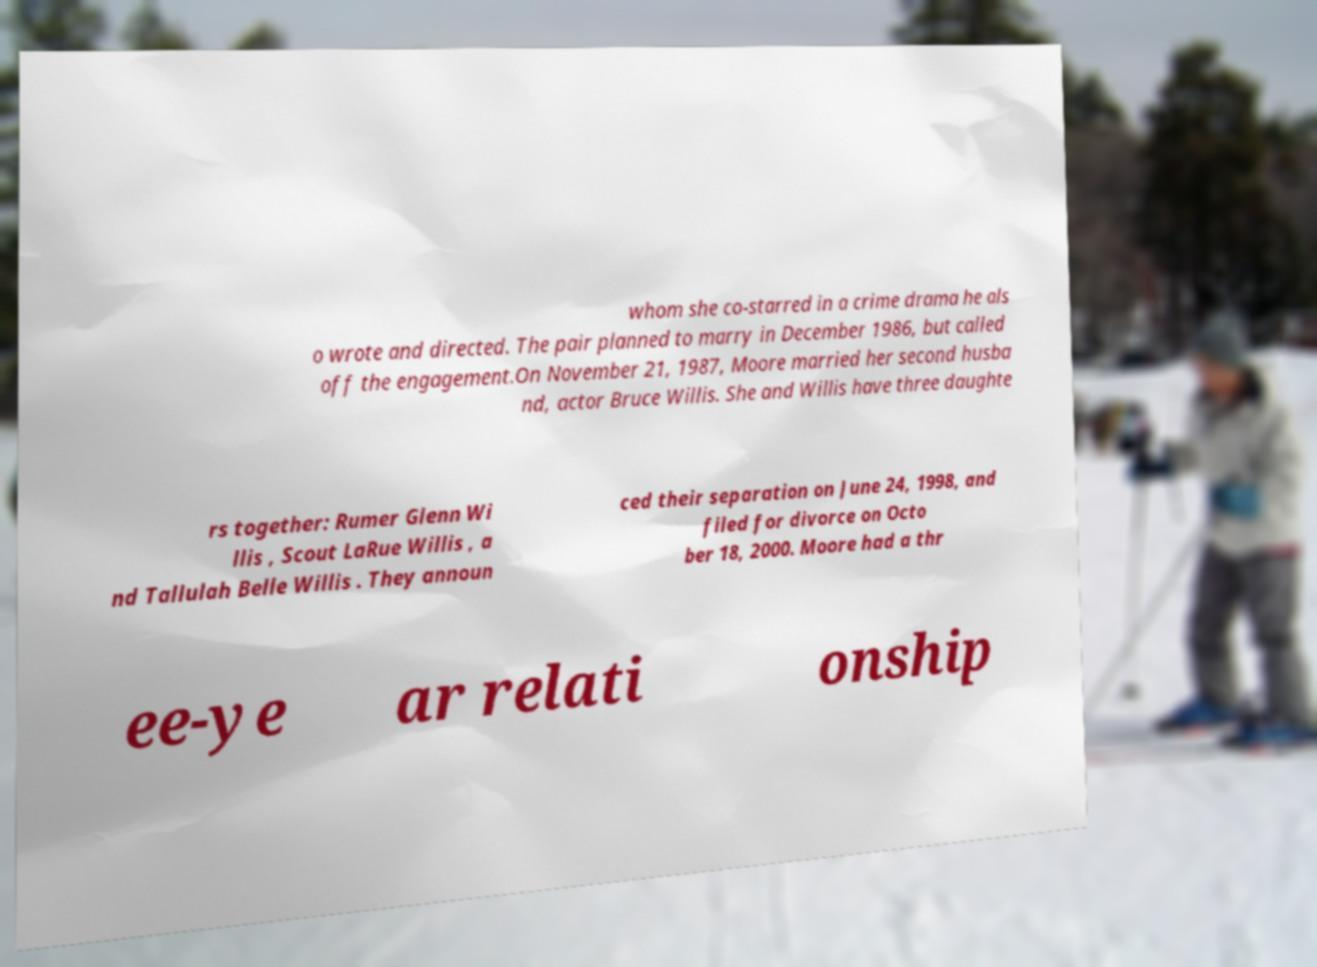Can you read and provide the text displayed in the image?This photo seems to have some interesting text. Can you extract and type it out for me? whom she co-starred in a crime drama he als o wrote and directed. The pair planned to marry in December 1986, but called off the engagement.On November 21, 1987, Moore married her second husba nd, actor Bruce Willis. She and Willis have three daughte rs together: Rumer Glenn Wi llis , Scout LaRue Willis , a nd Tallulah Belle Willis . They announ ced their separation on June 24, 1998, and filed for divorce on Octo ber 18, 2000. Moore had a thr ee-ye ar relati onship 